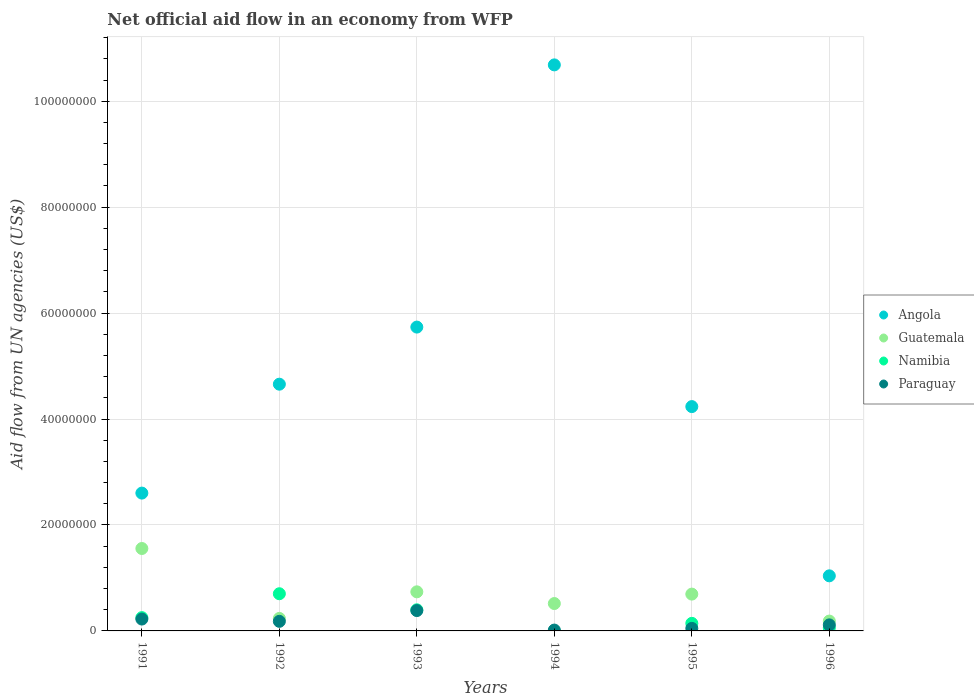What is the net official aid flow in Paraguay in 1994?
Give a very brief answer. 1.60e+05. Across all years, what is the maximum net official aid flow in Paraguay?
Keep it short and to the point. 3.84e+06. Across all years, what is the minimum net official aid flow in Guatemala?
Your answer should be very brief. 1.86e+06. In which year was the net official aid flow in Paraguay maximum?
Offer a terse response. 1993. What is the total net official aid flow in Guatemala in the graph?
Your response must be concise. 3.93e+07. What is the difference between the net official aid flow in Paraguay in 1992 and that in 1995?
Your answer should be compact. 1.33e+06. What is the difference between the net official aid flow in Guatemala in 1993 and the net official aid flow in Angola in 1995?
Give a very brief answer. -3.50e+07. What is the average net official aid flow in Paraguay per year?
Provide a succinct answer. 1.61e+06. In the year 1993, what is the difference between the net official aid flow in Guatemala and net official aid flow in Namibia?
Your answer should be very brief. 3.39e+06. In how many years, is the net official aid flow in Namibia greater than 8000000 US$?
Provide a succinct answer. 0. What is the ratio of the net official aid flow in Guatemala in 1991 to that in 1992?
Offer a terse response. 6.59. Is the net official aid flow in Paraguay in 1993 less than that in 1996?
Your answer should be compact. No. What is the difference between the highest and the second highest net official aid flow in Guatemala?
Give a very brief answer. 8.18e+06. What is the difference between the highest and the lowest net official aid flow in Paraguay?
Ensure brevity in your answer.  3.68e+06. Is it the case that in every year, the sum of the net official aid flow in Guatemala and net official aid flow in Paraguay  is greater than the sum of net official aid flow in Angola and net official aid flow in Namibia?
Provide a succinct answer. No. Is it the case that in every year, the sum of the net official aid flow in Guatemala and net official aid flow in Namibia  is greater than the net official aid flow in Paraguay?
Your answer should be very brief. Yes. Are the values on the major ticks of Y-axis written in scientific E-notation?
Ensure brevity in your answer.  No. Does the graph contain any zero values?
Your response must be concise. Yes. Does the graph contain grids?
Keep it short and to the point. Yes. Where does the legend appear in the graph?
Offer a very short reply. Center right. How many legend labels are there?
Offer a terse response. 4. What is the title of the graph?
Keep it short and to the point. Net official aid flow in an economy from WFP. Does "Heavily indebted poor countries" appear as one of the legend labels in the graph?
Provide a succinct answer. No. What is the label or title of the Y-axis?
Ensure brevity in your answer.  Aid flow from UN agencies (US$). What is the Aid flow from UN agencies (US$) of Angola in 1991?
Offer a terse response. 2.60e+07. What is the Aid flow from UN agencies (US$) of Guatemala in 1991?
Provide a succinct answer. 1.56e+07. What is the Aid flow from UN agencies (US$) in Namibia in 1991?
Offer a terse response. 2.51e+06. What is the Aid flow from UN agencies (US$) of Paraguay in 1991?
Your response must be concise. 2.24e+06. What is the Aid flow from UN agencies (US$) of Angola in 1992?
Offer a terse response. 4.66e+07. What is the Aid flow from UN agencies (US$) of Guatemala in 1992?
Offer a terse response. 2.36e+06. What is the Aid flow from UN agencies (US$) in Namibia in 1992?
Offer a very short reply. 7.02e+06. What is the Aid flow from UN agencies (US$) of Paraguay in 1992?
Your answer should be compact. 1.81e+06. What is the Aid flow from UN agencies (US$) in Angola in 1993?
Offer a terse response. 5.74e+07. What is the Aid flow from UN agencies (US$) in Guatemala in 1993?
Give a very brief answer. 7.38e+06. What is the Aid flow from UN agencies (US$) of Namibia in 1993?
Keep it short and to the point. 3.99e+06. What is the Aid flow from UN agencies (US$) of Paraguay in 1993?
Offer a very short reply. 3.84e+06. What is the Aid flow from UN agencies (US$) of Angola in 1994?
Your answer should be compact. 1.07e+08. What is the Aid flow from UN agencies (US$) in Guatemala in 1994?
Provide a short and direct response. 5.17e+06. What is the Aid flow from UN agencies (US$) of Namibia in 1994?
Make the answer very short. 0. What is the Aid flow from UN agencies (US$) in Angola in 1995?
Offer a terse response. 4.24e+07. What is the Aid flow from UN agencies (US$) of Guatemala in 1995?
Provide a succinct answer. 6.95e+06. What is the Aid flow from UN agencies (US$) of Namibia in 1995?
Provide a short and direct response. 1.43e+06. What is the Aid flow from UN agencies (US$) of Angola in 1996?
Your answer should be compact. 1.04e+07. What is the Aid flow from UN agencies (US$) in Guatemala in 1996?
Make the answer very short. 1.86e+06. What is the Aid flow from UN agencies (US$) of Namibia in 1996?
Your response must be concise. 5.70e+05. What is the Aid flow from UN agencies (US$) in Paraguay in 1996?
Your response must be concise. 1.14e+06. Across all years, what is the maximum Aid flow from UN agencies (US$) in Angola?
Your response must be concise. 1.07e+08. Across all years, what is the maximum Aid flow from UN agencies (US$) in Guatemala?
Offer a very short reply. 1.56e+07. Across all years, what is the maximum Aid flow from UN agencies (US$) in Namibia?
Offer a very short reply. 7.02e+06. Across all years, what is the maximum Aid flow from UN agencies (US$) of Paraguay?
Your answer should be compact. 3.84e+06. Across all years, what is the minimum Aid flow from UN agencies (US$) in Angola?
Your answer should be very brief. 1.04e+07. Across all years, what is the minimum Aid flow from UN agencies (US$) of Guatemala?
Your answer should be very brief. 1.86e+06. Across all years, what is the minimum Aid flow from UN agencies (US$) of Namibia?
Ensure brevity in your answer.  0. What is the total Aid flow from UN agencies (US$) in Angola in the graph?
Provide a succinct answer. 2.90e+08. What is the total Aid flow from UN agencies (US$) in Guatemala in the graph?
Offer a terse response. 3.93e+07. What is the total Aid flow from UN agencies (US$) of Namibia in the graph?
Keep it short and to the point. 1.55e+07. What is the total Aid flow from UN agencies (US$) in Paraguay in the graph?
Your answer should be compact. 9.67e+06. What is the difference between the Aid flow from UN agencies (US$) in Angola in 1991 and that in 1992?
Give a very brief answer. -2.06e+07. What is the difference between the Aid flow from UN agencies (US$) in Guatemala in 1991 and that in 1992?
Provide a short and direct response. 1.32e+07. What is the difference between the Aid flow from UN agencies (US$) of Namibia in 1991 and that in 1992?
Make the answer very short. -4.51e+06. What is the difference between the Aid flow from UN agencies (US$) of Angola in 1991 and that in 1993?
Provide a short and direct response. -3.13e+07. What is the difference between the Aid flow from UN agencies (US$) in Guatemala in 1991 and that in 1993?
Offer a very short reply. 8.18e+06. What is the difference between the Aid flow from UN agencies (US$) of Namibia in 1991 and that in 1993?
Make the answer very short. -1.48e+06. What is the difference between the Aid flow from UN agencies (US$) of Paraguay in 1991 and that in 1993?
Your answer should be compact. -1.60e+06. What is the difference between the Aid flow from UN agencies (US$) of Angola in 1991 and that in 1994?
Make the answer very short. -8.08e+07. What is the difference between the Aid flow from UN agencies (US$) of Guatemala in 1991 and that in 1994?
Your response must be concise. 1.04e+07. What is the difference between the Aid flow from UN agencies (US$) in Paraguay in 1991 and that in 1994?
Provide a succinct answer. 2.08e+06. What is the difference between the Aid flow from UN agencies (US$) in Angola in 1991 and that in 1995?
Keep it short and to the point. -1.63e+07. What is the difference between the Aid flow from UN agencies (US$) of Guatemala in 1991 and that in 1995?
Make the answer very short. 8.61e+06. What is the difference between the Aid flow from UN agencies (US$) in Namibia in 1991 and that in 1995?
Make the answer very short. 1.08e+06. What is the difference between the Aid flow from UN agencies (US$) of Paraguay in 1991 and that in 1995?
Provide a short and direct response. 1.76e+06. What is the difference between the Aid flow from UN agencies (US$) of Angola in 1991 and that in 1996?
Ensure brevity in your answer.  1.56e+07. What is the difference between the Aid flow from UN agencies (US$) in Guatemala in 1991 and that in 1996?
Make the answer very short. 1.37e+07. What is the difference between the Aid flow from UN agencies (US$) of Namibia in 1991 and that in 1996?
Keep it short and to the point. 1.94e+06. What is the difference between the Aid flow from UN agencies (US$) of Paraguay in 1991 and that in 1996?
Your answer should be very brief. 1.10e+06. What is the difference between the Aid flow from UN agencies (US$) in Angola in 1992 and that in 1993?
Give a very brief answer. -1.08e+07. What is the difference between the Aid flow from UN agencies (US$) in Guatemala in 1992 and that in 1993?
Your response must be concise. -5.02e+06. What is the difference between the Aid flow from UN agencies (US$) of Namibia in 1992 and that in 1993?
Keep it short and to the point. 3.03e+06. What is the difference between the Aid flow from UN agencies (US$) in Paraguay in 1992 and that in 1993?
Provide a short and direct response. -2.03e+06. What is the difference between the Aid flow from UN agencies (US$) of Angola in 1992 and that in 1994?
Ensure brevity in your answer.  -6.03e+07. What is the difference between the Aid flow from UN agencies (US$) in Guatemala in 1992 and that in 1994?
Your answer should be compact. -2.81e+06. What is the difference between the Aid flow from UN agencies (US$) in Paraguay in 1992 and that in 1994?
Your answer should be very brief. 1.65e+06. What is the difference between the Aid flow from UN agencies (US$) of Angola in 1992 and that in 1995?
Keep it short and to the point. 4.23e+06. What is the difference between the Aid flow from UN agencies (US$) in Guatemala in 1992 and that in 1995?
Make the answer very short. -4.59e+06. What is the difference between the Aid flow from UN agencies (US$) in Namibia in 1992 and that in 1995?
Make the answer very short. 5.59e+06. What is the difference between the Aid flow from UN agencies (US$) of Paraguay in 1992 and that in 1995?
Give a very brief answer. 1.33e+06. What is the difference between the Aid flow from UN agencies (US$) of Angola in 1992 and that in 1996?
Your answer should be very brief. 3.62e+07. What is the difference between the Aid flow from UN agencies (US$) in Guatemala in 1992 and that in 1996?
Your answer should be compact. 5.00e+05. What is the difference between the Aid flow from UN agencies (US$) of Namibia in 1992 and that in 1996?
Keep it short and to the point. 6.45e+06. What is the difference between the Aid flow from UN agencies (US$) in Paraguay in 1992 and that in 1996?
Provide a short and direct response. 6.70e+05. What is the difference between the Aid flow from UN agencies (US$) in Angola in 1993 and that in 1994?
Your answer should be very brief. -4.95e+07. What is the difference between the Aid flow from UN agencies (US$) in Guatemala in 1993 and that in 1994?
Give a very brief answer. 2.21e+06. What is the difference between the Aid flow from UN agencies (US$) in Paraguay in 1993 and that in 1994?
Offer a very short reply. 3.68e+06. What is the difference between the Aid flow from UN agencies (US$) in Angola in 1993 and that in 1995?
Your answer should be compact. 1.50e+07. What is the difference between the Aid flow from UN agencies (US$) in Namibia in 1993 and that in 1995?
Offer a very short reply. 2.56e+06. What is the difference between the Aid flow from UN agencies (US$) in Paraguay in 1993 and that in 1995?
Ensure brevity in your answer.  3.36e+06. What is the difference between the Aid flow from UN agencies (US$) in Angola in 1993 and that in 1996?
Ensure brevity in your answer.  4.70e+07. What is the difference between the Aid flow from UN agencies (US$) in Guatemala in 1993 and that in 1996?
Offer a very short reply. 5.52e+06. What is the difference between the Aid flow from UN agencies (US$) of Namibia in 1993 and that in 1996?
Give a very brief answer. 3.42e+06. What is the difference between the Aid flow from UN agencies (US$) in Paraguay in 1993 and that in 1996?
Keep it short and to the point. 2.70e+06. What is the difference between the Aid flow from UN agencies (US$) in Angola in 1994 and that in 1995?
Ensure brevity in your answer.  6.45e+07. What is the difference between the Aid flow from UN agencies (US$) of Guatemala in 1994 and that in 1995?
Offer a very short reply. -1.78e+06. What is the difference between the Aid flow from UN agencies (US$) of Paraguay in 1994 and that in 1995?
Offer a terse response. -3.20e+05. What is the difference between the Aid flow from UN agencies (US$) in Angola in 1994 and that in 1996?
Provide a short and direct response. 9.65e+07. What is the difference between the Aid flow from UN agencies (US$) of Guatemala in 1994 and that in 1996?
Offer a very short reply. 3.31e+06. What is the difference between the Aid flow from UN agencies (US$) in Paraguay in 1994 and that in 1996?
Offer a very short reply. -9.80e+05. What is the difference between the Aid flow from UN agencies (US$) of Angola in 1995 and that in 1996?
Your response must be concise. 3.20e+07. What is the difference between the Aid flow from UN agencies (US$) in Guatemala in 1995 and that in 1996?
Your answer should be compact. 5.09e+06. What is the difference between the Aid flow from UN agencies (US$) of Namibia in 1995 and that in 1996?
Give a very brief answer. 8.60e+05. What is the difference between the Aid flow from UN agencies (US$) in Paraguay in 1995 and that in 1996?
Keep it short and to the point. -6.60e+05. What is the difference between the Aid flow from UN agencies (US$) of Angola in 1991 and the Aid flow from UN agencies (US$) of Guatemala in 1992?
Give a very brief answer. 2.37e+07. What is the difference between the Aid flow from UN agencies (US$) in Angola in 1991 and the Aid flow from UN agencies (US$) in Namibia in 1992?
Ensure brevity in your answer.  1.90e+07. What is the difference between the Aid flow from UN agencies (US$) in Angola in 1991 and the Aid flow from UN agencies (US$) in Paraguay in 1992?
Provide a short and direct response. 2.42e+07. What is the difference between the Aid flow from UN agencies (US$) of Guatemala in 1991 and the Aid flow from UN agencies (US$) of Namibia in 1992?
Keep it short and to the point. 8.54e+06. What is the difference between the Aid flow from UN agencies (US$) of Guatemala in 1991 and the Aid flow from UN agencies (US$) of Paraguay in 1992?
Your answer should be very brief. 1.38e+07. What is the difference between the Aid flow from UN agencies (US$) in Angola in 1991 and the Aid flow from UN agencies (US$) in Guatemala in 1993?
Provide a succinct answer. 1.86e+07. What is the difference between the Aid flow from UN agencies (US$) of Angola in 1991 and the Aid flow from UN agencies (US$) of Namibia in 1993?
Provide a succinct answer. 2.20e+07. What is the difference between the Aid flow from UN agencies (US$) in Angola in 1991 and the Aid flow from UN agencies (US$) in Paraguay in 1993?
Your answer should be compact. 2.22e+07. What is the difference between the Aid flow from UN agencies (US$) in Guatemala in 1991 and the Aid flow from UN agencies (US$) in Namibia in 1993?
Your answer should be compact. 1.16e+07. What is the difference between the Aid flow from UN agencies (US$) in Guatemala in 1991 and the Aid flow from UN agencies (US$) in Paraguay in 1993?
Keep it short and to the point. 1.17e+07. What is the difference between the Aid flow from UN agencies (US$) in Namibia in 1991 and the Aid flow from UN agencies (US$) in Paraguay in 1993?
Give a very brief answer. -1.33e+06. What is the difference between the Aid flow from UN agencies (US$) in Angola in 1991 and the Aid flow from UN agencies (US$) in Guatemala in 1994?
Give a very brief answer. 2.08e+07. What is the difference between the Aid flow from UN agencies (US$) of Angola in 1991 and the Aid flow from UN agencies (US$) of Paraguay in 1994?
Keep it short and to the point. 2.59e+07. What is the difference between the Aid flow from UN agencies (US$) in Guatemala in 1991 and the Aid flow from UN agencies (US$) in Paraguay in 1994?
Your answer should be compact. 1.54e+07. What is the difference between the Aid flow from UN agencies (US$) of Namibia in 1991 and the Aid flow from UN agencies (US$) of Paraguay in 1994?
Provide a succinct answer. 2.35e+06. What is the difference between the Aid flow from UN agencies (US$) in Angola in 1991 and the Aid flow from UN agencies (US$) in Guatemala in 1995?
Keep it short and to the point. 1.91e+07. What is the difference between the Aid flow from UN agencies (US$) in Angola in 1991 and the Aid flow from UN agencies (US$) in Namibia in 1995?
Provide a short and direct response. 2.46e+07. What is the difference between the Aid flow from UN agencies (US$) in Angola in 1991 and the Aid flow from UN agencies (US$) in Paraguay in 1995?
Offer a terse response. 2.55e+07. What is the difference between the Aid flow from UN agencies (US$) in Guatemala in 1991 and the Aid flow from UN agencies (US$) in Namibia in 1995?
Offer a terse response. 1.41e+07. What is the difference between the Aid flow from UN agencies (US$) in Guatemala in 1991 and the Aid flow from UN agencies (US$) in Paraguay in 1995?
Make the answer very short. 1.51e+07. What is the difference between the Aid flow from UN agencies (US$) of Namibia in 1991 and the Aid flow from UN agencies (US$) of Paraguay in 1995?
Offer a very short reply. 2.03e+06. What is the difference between the Aid flow from UN agencies (US$) of Angola in 1991 and the Aid flow from UN agencies (US$) of Guatemala in 1996?
Your answer should be compact. 2.42e+07. What is the difference between the Aid flow from UN agencies (US$) of Angola in 1991 and the Aid flow from UN agencies (US$) of Namibia in 1996?
Offer a terse response. 2.54e+07. What is the difference between the Aid flow from UN agencies (US$) in Angola in 1991 and the Aid flow from UN agencies (US$) in Paraguay in 1996?
Offer a terse response. 2.49e+07. What is the difference between the Aid flow from UN agencies (US$) in Guatemala in 1991 and the Aid flow from UN agencies (US$) in Namibia in 1996?
Offer a terse response. 1.50e+07. What is the difference between the Aid flow from UN agencies (US$) of Guatemala in 1991 and the Aid flow from UN agencies (US$) of Paraguay in 1996?
Make the answer very short. 1.44e+07. What is the difference between the Aid flow from UN agencies (US$) in Namibia in 1991 and the Aid flow from UN agencies (US$) in Paraguay in 1996?
Your response must be concise. 1.37e+06. What is the difference between the Aid flow from UN agencies (US$) of Angola in 1992 and the Aid flow from UN agencies (US$) of Guatemala in 1993?
Ensure brevity in your answer.  3.92e+07. What is the difference between the Aid flow from UN agencies (US$) of Angola in 1992 and the Aid flow from UN agencies (US$) of Namibia in 1993?
Keep it short and to the point. 4.26e+07. What is the difference between the Aid flow from UN agencies (US$) in Angola in 1992 and the Aid flow from UN agencies (US$) in Paraguay in 1993?
Provide a succinct answer. 4.27e+07. What is the difference between the Aid flow from UN agencies (US$) of Guatemala in 1992 and the Aid flow from UN agencies (US$) of Namibia in 1993?
Give a very brief answer. -1.63e+06. What is the difference between the Aid flow from UN agencies (US$) of Guatemala in 1992 and the Aid flow from UN agencies (US$) of Paraguay in 1993?
Your response must be concise. -1.48e+06. What is the difference between the Aid flow from UN agencies (US$) in Namibia in 1992 and the Aid flow from UN agencies (US$) in Paraguay in 1993?
Your response must be concise. 3.18e+06. What is the difference between the Aid flow from UN agencies (US$) of Angola in 1992 and the Aid flow from UN agencies (US$) of Guatemala in 1994?
Make the answer very short. 4.14e+07. What is the difference between the Aid flow from UN agencies (US$) in Angola in 1992 and the Aid flow from UN agencies (US$) in Paraguay in 1994?
Your response must be concise. 4.64e+07. What is the difference between the Aid flow from UN agencies (US$) in Guatemala in 1992 and the Aid flow from UN agencies (US$) in Paraguay in 1994?
Make the answer very short. 2.20e+06. What is the difference between the Aid flow from UN agencies (US$) of Namibia in 1992 and the Aid flow from UN agencies (US$) of Paraguay in 1994?
Keep it short and to the point. 6.86e+06. What is the difference between the Aid flow from UN agencies (US$) in Angola in 1992 and the Aid flow from UN agencies (US$) in Guatemala in 1995?
Offer a terse response. 3.96e+07. What is the difference between the Aid flow from UN agencies (US$) of Angola in 1992 and the Aid flow from UN agencies (US$) of Namibia in 1995?
Provide a succinct answer. 4.52e+07. What is the difference between the Aid flow from UN agencies (US$) in Angola in 1992 and the Aid flow from UN agencies (US$) in Paraguay in 1995?
Your answer should be very brief. 4.61e+07. What is the difference between the Aid flow from UN agencies (US$) in Guatemala in 1992 and the Aid flow from UN agencies (US$) in Namibia in 1995?
Give a very brief answer. 9.30e+05. What is the difference between the Aid flow from UN agencies (US$) in Guatemala in 1992 and the Aid flow from UN agencies (US$) in Paraguay in 1995?
Your response must be concise. 1.88e+06. What is the difference between the Aid flow from UN agencies (US$) of Namibia in 1992 and the Aid flow from UN agencies (US$) of Paraguay in 1995?
Your answer should be very brief. 6.54e+06. What is the difference between the Aid flow from UN agencies (US$) in Angola in 1992 and the Aid flow from UN agencies (US$) in Guatemala in 1996?
Ensure brevity in your answer.  4.47e+07. What is the difference between the Aid flow from UN agencies (US$) of Angola in 1992 and the Aid flow from UN agencies (US$) of Namibia in 1996?
Keep it short and to the point. 4.60e+07. What is the difference between the Aid flow from UN agencies (US$) in Angola in 1992 and the Aid flow from UN agencies (US$) in Paraguay in 1996?
Your response must be concise. 4.54e+07. What is the difference between the Aid flow from UN agencies (US$) of Guatemala in 1992 and the Aid flow from UN agencies (US$) of Namibia in 1996?
Keep it short and to the point. 1.79e+06. What is the difference between the Aid flow from UN agencies (US$) in Guatemala in 1992 and the Aid flow from UN agencies (US$) in Paraguay in 1996?
Offer a very short reply. 1.22e+06. What is the difference between the Aid flow from UN agencies (US$) of Namibia in 1992 and the Aid flow from UN agencies (US$) of Paraguay in 1996?
Your response must be concise. 5.88e+06. What is the difference between the Aid flow from UN agencies (US$) in Angola in 1993 and the Aid flow from UN agencies (US$) in Guatemala in 1994?
Your answer should be very brief. 5.22e+07. What is the difference between the Aid flow from UN agencies (US$) of Angola in 1993 and the Aid flow from UN agencies (US$) of Paraguay in 1994?
Your response must be concise. 5.72e+07. What is the difference between the Aid flow from UN agencies (US$) in Guatemala in 1993 and the Aid flow from UN agencies (US$) in Paraguay in 1994?
Your answer should be very brief. 7.22e+06. What is the difference between the Aid flow from UN agencies (US$) of Namibia in 1993 and the Aid flow from UN agencies (US$) of Paraguay in 1994?
Provide a succinct answer. 3.83e+06. What is the difference between the Aid flow from UN agencies (US$) of Angola in 1993 and the Aid flow from UN agencies (US$) of Guatemala in 1995?
Offer a very short reply. 5.04e+07. What is the difference between the Aid flow from UN agencies (US$) of Angola in 1993 and the Aid flow from UN agencies (US$) of Namibia in 1995?
Your answer should be very brief. 5.59e+07. What is the difference between the Aid flow from UN agencies (US$) in Angola in 1993 and the Aid flow from UN agencies (US$) in Paraguay in 1995?
Your answer should be compact. 5.69e+07. What is the difference between the Aid flow from UN agencies (US$) in Guatemala in 1993 and the Aid flow from UN agencies (US$) in Namibia in 1995?
Offer a terse response. 5.95e+06. What is the difference between the Aid flow from UN agencies (US$) of Guatemala in 1993 and the Aid flow from UN agencies (US$) of Paraguay in 1995?
Give a very brief answer. 6.90e+06. What is the difference between the Aid flow from UN agencies (US$) of Namibia in 1993 and the Aid flow from UN agencies (US$) of Paraguay in 1995?
Your answer should be very brief. 3.51e+06. What is the difference between the Aid flow from UN agencies (US$) in Angola in 1993 and the Aid flow from UN agencies (US$) in Guatemala in 1996?
Offer a terse response. 5.55e+07. What is the difference between the Aid flow from UN agencies (US$) in Angola in 1993 and the Aid flow from UN agencies (US$) in Namibia in 1996?
Your answer should be very brief. 5.68e+07. What is the difference between the Aid flow from UN agencies (US$) of Angola in 1993 and the Aid flow from UN agencies (US$) of Paraguay in 1996?
Your response must be concise. 5.62e+07. What is the difference between the Aid flow from UN agencies (US$) of Guatemala in 1993 and the Aid flow from UN agencies (US$) of Namibia in 1996?
Provide a short and direct response. 6.81e+06. What is the difference between the Aid flow from UN agencies (US$) in Guatemala in 1993 and the Aid flow from UN agencies (US$) in Paraguay in 1996?
Your answer should be compact. 6.24e+06. What is the difference between the Aid flow from UN agencies (US$) of Namibia in 1993 and the Aid flow from UN agencies (US$) of Paraguay in 1996?
Keep it short and to the point. 2.85e+06. What is the difference between the Aid flow from UN agencies (US$) in Angola in 1994 and the Aid flow from UN agencies (US$) in Guatemala in 1995?
Your answer should be very brief. 9.99e+07. What is the difference between the Aid flow from UN agencies (US$) in Angola in 1994 and the Aid flow from UN agencies (US$) in Namibia in 1995?
Make the answer very short. 1.05e+08. What is the difference between the Aid flow from UN agencies (US$) of Angola in 1994 and the Aid flow from UN agencies (US$) of Paraguay in 1995?
Your answer should be very brief. 1.06e+08. What is the difference between the Aid flow from UN agencies (US$) in Guatemala in 1994 and the Aid flow from UN agencies (US$) in Namibia in 1995?
Provide a short and direct response. 3.74e+06. What is the difference between the Aid flow from UN agencies (US$) of Guatemala in 1994 and the Aid flow from UN agencies (US$) of Paraguay in 1995?
Provide a succinct answer. 4.69e+06. What is the difference between the Aid flow from UN agencies (US$) in Angola in 1994 and the Aid flow from UN agencies (US$) in Guatemala in 1996?
Your response must be concise. 1.05e+08. What is the difference between the Aid flow from UN agencies (US$) of Angola in 1994 and the Aid flow from UN agencies (US$) of Namibia in 1996?
Offer a very short reply. 1.06e+08. What is the difference between the Aid flow from UN agencies (US$) in Angola in 1994 and the Aid flow from UN agencies (US$) in Paraguay in 1996?
Your answer should be very brief. 1.06e+08. What is the difference between the Aid flow from UN agencies (US$) of Guatemala in 1994 and the Aid flow from UN agencies (US$) of Namibia in 1996?
Give a very brief answer. 4.60e+06. What is the difference between the Aid flow from UN agencies (US$) of Guatemala in 1994 and the Aid flow from UN agencies (US$) of Paraguay in 1996?
Give a very brief answer. 4.03e+06. What is the difference between the Aid flow from UN agencies (US$) in Angola in 1995 and the Aid flow from UN agencies (US$) in Guatemala in 1996?
Offer a very short reply. 4.05e+07. What is the difference between the Aid flow from UN agencies (US$) of Angola in 1995 and the Aid flow from UN agencies (US$) of Namibia in 1996?
Offer a very short reply. 4.18e+07. What is the difference between the Aid flow from UN agencies (US$) in Angola in 1995 and the Aid flow from UN agencies (US$) in Paraguay in 1996?
Offer a very short reply. 4.12e+07. What is the difference between the Aid flow from UN agencies (US$) of Guatemala in 1995 and the Aid flow from UN agencies (US$) of Namibia in 1996?
Ensure brevity in your answer.  6.38e+06. What is the difference between the Aid flow from UN agencies (US$) of Guatemala in 1995 and the Aid flow from UN agencies (US$) of Paraguay in 1996?
Your response must be concise. 5.81e+06. What is the difference between the Aid flow from UN agencies (US$) of Namibia in 1995 and the Aid flow from UN agencies (US$) of Paraguay in 1996?
Provide a short and direct response. 2.90e+05. What is the average Aid flow from UN agencies (US$) in Angola per year?
Keep it short and to the point. 4.83e+07. What is the average Aid flow from UN agencies (US$) of Guatemala per year?
Provide a short and direct response. 6.55e+06. What is the average Aid flow from UN agencies (US$) in Namibia per year?
Make the answer very short. 2.59e+06. What is the average Aid flow from UN agencies (US$) of Paraguay per year?
Make the answer very short. 1.61e+06. In the year 1991, what is the difference between the Aid flow from UN agencies (US$) in Angola and Aid flow from UN agencies (US$) in Guatemala?
Your answer should be compact. 1.05e+07. In the year 1991, what is the difference between the Aid flow from UN agencies (US$) in Angola and Aid flow from UN agencies (US$) in Namibia?
Provide a succinct answer. 2.35e+07. In the year 1991, what is the difference between the Aid flow from UN agencies (US$) in Angola and Aid flow from UN agencies (US$) in Paraguay?
Offer a terse response. 2.38e+07. In the year 1991, what is the difference between the Aid flow from UN agencies (US$) of Guatemala and Aid flow from UN agencies (US$) of Namibia?
Your response must be concise. 1.30e+07. In the year 1991, what is the difference between the Aid flow from UN agencies (US$) of Guatemala and Aid flow from UN agencies (US$) of Paraguay?
Offer a very short reply. 1.33e+07. In the year 1992, what is the difference between the Aid flow from UN agencies (US$) in Angola and Aid flow from UN agencies (US$) in Guatemala?
Your answer should be very brief. 4.42e+07. In the year 1992, what is the difference between the Aid flow from UN agencies (US$) of Angola and Aid flow from UN agencies (US$) of Namibia?
Offer a very short reply. 3.96e+07. In the year 1992, what is the difference between the Aid flow from UN agencies (US$) in Angola and Aid flow from UN agencies (US$) in Paraguay?
Keep it short and to the point. 4.48e+07. In the year 1992, what is the difference between the Aid flow from UN agencies (US$) of Guatemala and Aid flow from UN agencies (US$) of Namibia?
Offer a terse response. -4.66e+06. In the year 1992, what is the difference between the Aid flow from UN agencies (US$) in Guatemala and Aid flow from UN agencies (US$) in Paraguay?
Your answer should be compact. 5.50e+05. In the year 1992, what is the difference between the Aid flow from UN agencies (US$) in Namibia and Aid flow from UN agencies (US$) in Paraguay?
Your answer should be very brief. 5.21e+06. In the year 1993, what is the difference between the Aid flow from UN agencies (US$) of Angola and Aid flow from UN agencies (US$) of Guatemala?
Your answer should be compact. 5.00e+07. In the year 1993, what is the difference between the Aid flow from UN agencies (US$) of Angola and Aid flow from UN agencies (US$) of Namibia?
Offer a terse response. 5.34e+07. In the year 1993, what is the difference between the Aid flow from UN agencies (US$) of Angola and Aid flow from UN agencies (US$) of Paraguay?
Keep it short and to the point. 5.35e+07. In the year 1993, what is the difference between the Aid flow from UN agencies (US$) in Guatemala and Aid flow from UN agencies (US$) in Namibia?
Offer a very short reply. 3.39e+06. In the year 1993, what is the difference between the Aid flow from UN agencies (US$) of Guatemala and Aid flow from UN agencies (US$) of Paraguay?
Keep it short and to the point. 3.54e+06. In the year 1993, what is the difference between the Aid flow from UN agencies (US$) of Namibia and Aid flow from UN agencies (US$) of Paraguay?
Provide a short and direct response. 1.50e+05. In the year 1994, what is the difference between the Aid flow from UN agencies (US$) of Angola and Aid flow from UN agencies (US$) of Guatemala?
Your response must be concise. 1.02e+08. In the year 1994, what is the difference between the Aid flow from UN agencies (US$) of Angola and Aid flow from UN agencies (US$) of Paraguay?
Offer a terse response. 1.07e+08. In the year 1994, what is the difference between the Aid flow from UN agencies (US$) in Guatemala and Aid flow from UN agencies (US$) in Paraguay?
Your response must be concise. 5.01e+06. In the year 1995, what is the difference between the Aid flow from UN agencies (US$) of Angola and Aid flow from UN agencies (US$) of Guatemala?
Offer a very short reply. 3.54e+07. In the year 1995, what is the difference between the Aid flow from UN agencies (US$) in Angola and Aid flow from UN agencies (US$) in Namibia?
Make the answer very short. 4.09e+07. In the year 1995, what is the difference between the Aid flow from UN agencies (US$) of Angola and Aid flow from UN agencies (US$) of Paraguay?
Give a very brief answer. 4.19e+07. In the year 1995, what is the difference between the Aid flow from UN agencies (US$) of Guatemala and Aid flow from UN agencies (US$) of Namibia?
Your answer should be compact. 5.52e+06. In the year 1995, what is the difference between the Aid flow from UN agencies (US$) of Guatemala and Aid flow from UN agencies (US$) of Paraguay?
Offer a very short reply. 6.47e+06. In the year 1995, what is the difference between the Aid flow from UN agencies (US$) of Namibia and Aid flow from UN agencies (US$) of Paraguay?
Your answer should be very brief. 9.50e+05. In the year 1996, what is the difference between the Aid flow from UN agencies (US$) in Angola and Aid flow from UN agencies (US$) in Guatemala?
Your answer should be very brief. 8.54e+06. In the year 1996, what is the difference between the Aid flow from UN agencies (US$) in Angola and Aid flow from UN agencies (US$) in Namibia?
Your response must be concise. 9.83e+06. In the year 1996, what is the difference between the Aid flow from UN agencies (US$) in Angola and Aid flow from UN agencies (US$) in Paraguay?
Offer a terse response. 9.26e+06. In the year 1996, what is the difference between the Aid flow from UN agencies (US$) of Guatemala and Aid flow from UN agencies (US$) of Namibia?
Your response must be concise. 1.29e+06. In the year 1996, what is the difference between the Aid flow from UN agencies (US$) of Guatemala and Aid flow from UN agencies (US$) of Paraguay?
Your answer should be very brief. 7.20e+05. In the year 1996, what is the difference between the Aid flow from UN agencies (US$) in Namibia and Aid flow from UN agencies (US$) in Paraguay?
Make the answer very short. -5.70e+05. What is the ratio of the Aid flow from UN agencies (US$) in Angola in 1991 to that in 1992?
Your response must be concise. 0.56. What is the ratio of the Aid flow from UN agencies (US$) in Guatemala in 1991 to that in 1992?
Offer a terse response. 6.59. What is the ratio of the Aid flow from UN agencies (US$) in Namibia in 1991 to that in 1992?
Keep it short and to the point. 0.36. What is the ratio of the Aid flow from UN agencies (US$) of Paraguay in 1991 to that in 1992?
Your answer should be very brief. 1.24. What is the ratio of the Aid flow from UN agencies (US$) of Angola in 1991 to that in 1993?
Give a very brief answer. 0.45. What is the ratio of the Aid flow from UN agencies (US$) in Guatemala in 1991 to that in 1993?
Offer a very short reply. 2.11. What is the ratio of the Aid flow from UN agencies (US$) of Namibia in 1991 to that in 1993?
Provide a succinct answer. 0.63. What is the ratio of the Aid flow from UN agencies (US$) in Paraguay in 1991 to that in 1993?
Your answer should be very brief. 0.58. What is the ratio of the Aid flow from UN agencies (US$) of Angola in 1991 to that in 1994?
Your response must be concise. 0.24. What is the ratio of the Aid flow from UN agencies (US$) of Guatemala in 1991 to that in 1994?
Keep it short and to the point. 3.01. What is the ratio of the Aid flow from UN agencies (US$) in Angola in 1991 to that in 1995?
Your answer should be compact. 0.61. What is the ratio of the Aid flow from UN agencies (US$) of Guatemala in 1991 to that in 1995?
Provide a short and direct response. 2.24. What is the ratio of the Aid flow from UN agencies (US$) of Namibia in 1991 to that in 1995?
Provide a succinct answer. 1.76. What is the ratio of the Aid flow from UN agencies (US$) in Paraguay in 1991 to that in 1995?
Provide a short and direct response. 4.67. What is the ratio of the Aid flow from UN agencies (US$) in Angola in 1991 to that in 1996?
Your answer should be very brief. 2.5. What is the ratio of the Aid flow from UN agencies (US$) of Guatemala in 1991 to that in 1996?
Make the answer very short. 8.37. What is the ratio of the Aid flow from UN agencies (US$) in Namibia in 1991 to that in 1996?
Keep it short and to the point. 4.4. What is the ratio of the Aid flow from UN agencies (US$) of Paraguay in 1991 to that in 1996?
Provide a succinct answer. 1.96. What is the ratio of the Aid flow from UN agencies (US$) in Angola in 1992 to that in 1993?
Ensure brevity in your answer.  0.81. What is the ratio of the Aid flow from UN agencies (US$) of Guatemala in 1992 to that in 1993?
Ensure brevity in your answer.  0.32. What is the ratio of the Aid flow from UN agencies (US$) in Namibia in 1992 to that in 1993?
Make the answer very short. 1.76. What is the ratio of the Aid flow from UN agencies (US$) in Paraguay in 1992 to that in 1993?
Ensure brevity in your answer.  0.47. What is the ratio of the Aid flow from UN agencies (US$) in Angola in 1992 to that in 1994?
Provide a succinct answer. 0.44. What is the ratio of the Aid flow from UN agencies (US$) in Guatemala in 1992 to that in 1994?
Keep it short and to the point. 0.46. What is the ratio of the Aid flow from UN agencies (US$) in Paraguay in 1992 to that in 1994?
Provide a short and direct response. 11.31. What is the ratio of the Aid flow from UN agencies (US$) of Angola in 1992 to that in 1995?
Your response must be concise. 1.1. What is the ratio of the Aid flow from UN agencies (US$) in Guatemala in 1992 to that in 1995?
Your answer should be very brief. 0.34. What is the ratio of the Aid flow from UN agencies (US$) in Namibia in 1992 to that in 1995?
Your answer should be compact. 4.91. What is the ratio of the Aid flow from UN agencies (US$) in Paraguay in 1992 to that in 1995?
Ensure brevity in your answer.  3.77. What is the ratio of the Aid flow from UN agencies (US$) in Angola in 1992 to that in 1996?
Your answer should be very brief. 4.48. What is the ratio of the Aid flow from UN agencies (US$) in Guatemala in 1992 to that in 1996?
Keep it short and to the point. 1.27. What is the ratio of the Aid flow from UN agencies (US$) of Namibia in 1992 to that in 1996?
Your answer should be very brief. 12.32. What is the ratio of the Aid flow from UN agencies (US$) in Paraguay in 1992 to that in 1996?
Give a very brief answer. 1.59. What is the ratio of the Aid flow from UN agencies (US$) in Angola in 1993 to that in 1994?
Offer a very short reply. 0.54. What is the ratio of the Aid flow from UN agencies (US$) of Guatemala in 1993 to that in 1994?
Provide a succinct answer. 1.43. What is the ratio of the Aid flow from UN agencies (US$) of Paraguay in 1993 to that in 1994?
Your answer should be compact. 24. What is the ratio of the Aid flow from UN agencies (US$) in Angola in 1993 to that in 1995?
Ensure brevity in your answer.  1.35. What is the ratio of the Aid flow from UN agencies (US$) in Guatemala in 1993 to that in 1995?
Your answer should be compact. 1.06. What is the ratio of the Aid flow from UN agencies (US$) in Namibia in 1993 to that in 1995?
Your response must be concise. 2.79. What is the ratio of the Aid flow from UN agencies (US$) in Paraguay in 1993 to that in 1995?
Make the answer very short. 8. What is the ratio of the Aid flow from UN agencies (US$) of Angola in 1993 to that in 1996?
Your answer should be very brief. 5.52. What is the ratio of the Aid flow from UN agencies (US$) of Guatemala in 1993 to that in 1996?
Give a very brief answer. 3.97. What is the ratio of the Aid flow from UN agencies (US$) in Namibia in 1993 to that in 1996?
Offer a terse response. 7. What is the ratio of the Aid flow from UN agencies (US$) of Paraguay in 1993 to that in 1996?
Make the answer very short. 3.37. What is the ratio of the Aid flow from UN agencies (US$) in Angola in 1994 to that in 1995?
Your response must be concise. 2.52. What is the ratio of the Aid flow from UN agencies (US$) in Guatemala in 1994 to that in 1995?
Your answer should be very brief. 0.74. What is the ratio of the Aid flow from UN agencies (US$) of Paraguay in 1994 to that in 1995?
Make the answer very short. 0.33. What is the ratio of the Aid flow from UN agencies (US$) of Angola in 1994 to that in 1996?
Give a very brief answer. 10.28. What is the ratio of the Aid flow from UN agencies (US$) of Guatemala in 1994 to that in 1996?
Ensure brevity in your answer.  2.78. What is the ratio of the Aid flow from UN agencies (US$) of Paraguay in 1994 to that in 1996?
Provide a short and direct response. 0.14. What is the ratio of the Aid flow from UN agencies (US$) of Angola in 1995 to that in 1996?
Offer a very short reply. 4.07. What is the ratio of the Aid flow from UN agencies (US$) in Guatemala in 1995 to that in 1996?
Your answer should be compact. 3.74. What is the ratio of the Aid flow from UN agencies (US$) of Namibia in 1995 to that in 1996?
Keep it short and to the point. 2.51. What is the ratio of the Aid flow from UN agencies (US$) of Paraguay in 1995 to that in 1996?
Your answer should be compact. 0.42. What is the difference between the highest and the second highest Aid flow from UN agencies (US$) of Angola?
Offer a terse response. 4.95e+07. What is the difference between the highest and the second highest Aid flow from UN agencies (US$) of Guatemala?
Provide a succinct answer. 8.18e+06. What is the difference between the highest and the second highest Aid flow from UN agencies (US$) of Namibia?
Provide a short and direct response. 3.03e+06. What is the difference between the highest and the second highest Aid flow from UN agencies (US$) of Paraguay?
Offer a terse response. 1.60e+06. What is the difference between the highest and the lowest Aid flow from UN agencies (US$) of Angola?
Make the answer very short. 9.65e+07. What is the difference between the highest and the lowest Aid flow from UN agencies (US$) of Guatemala?
Make the answer very short. 1.37e+07. What is the difference between the highest and the lowest Aid flow from UN agencies (US$) in Namibia?
Provide a short and direct response. 7.02e+06. What is the difference between the highest and the lowest Aid flow from UN agencies (US$) of Paraguay?
Offer a very short reply. 3.68e+06. 